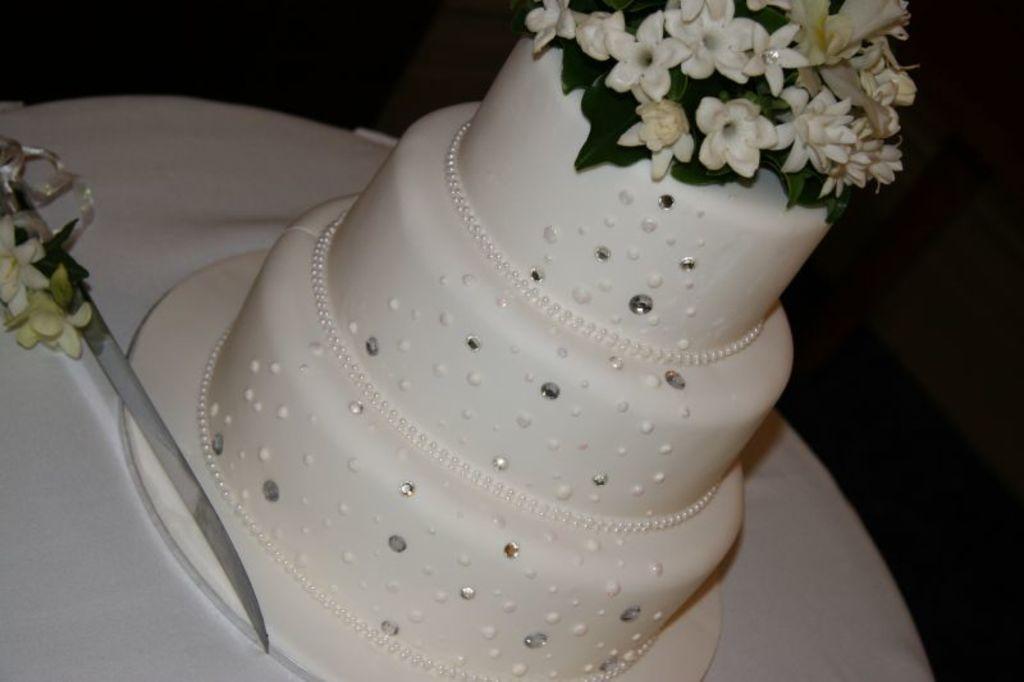Can you describe this image briefly? In this image there is a three tier cake placed on a table, beside the cake there is a knife. 